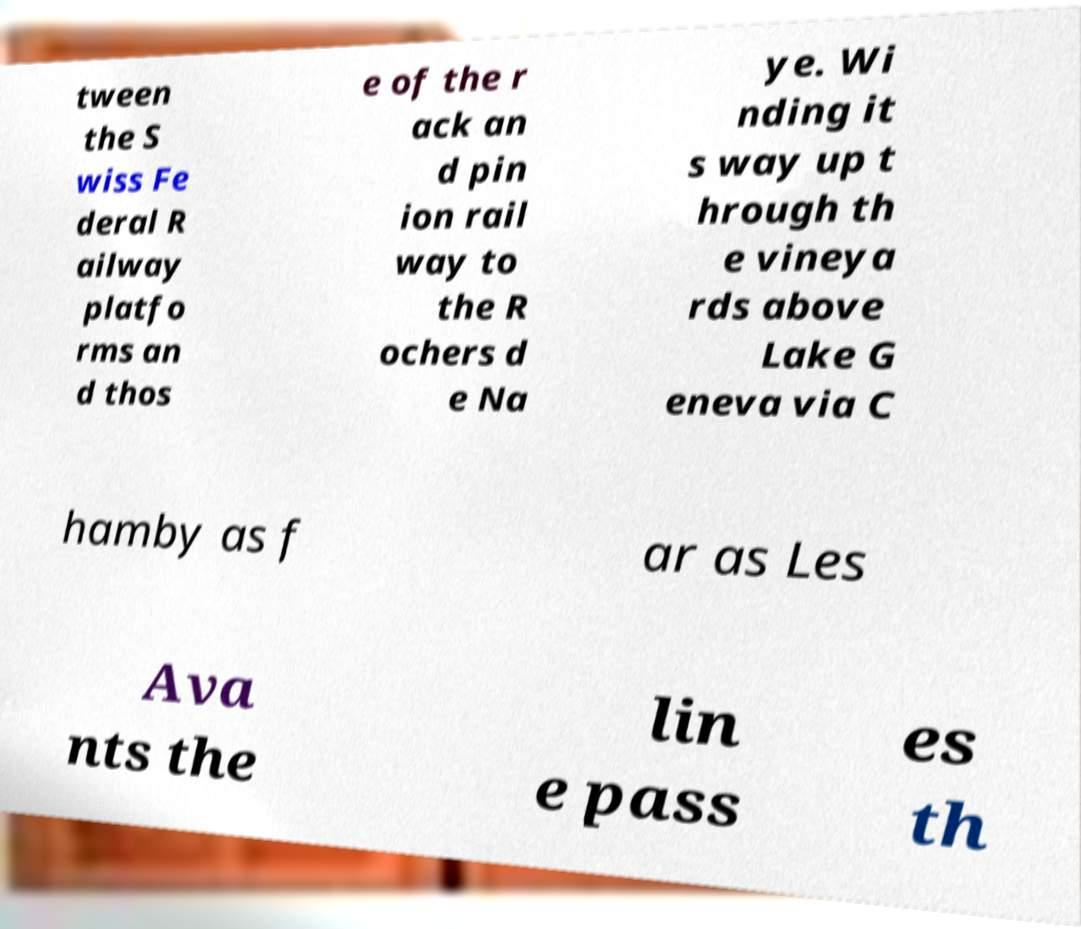For documentation purposes, I need the text within this image transcribed. Could you provide that? tween the S wiss Fe deral R ailway platfo rms an d thos e of the r ack an d pin ion rail way to the R ochers d e Na ye. Wi nding it s way up t hrough th e vineya rds above Lake G eneva via C hamby as f ar as Les Ava nts the lin e pass es th 